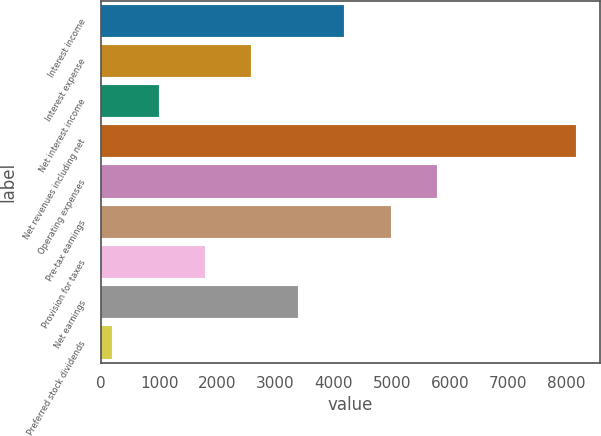Convert chart. <chart><loc_0><loc_0><loc_500><loc_500><bar_chart><fcel>Interest income<fcel>Interest expense<fcel>Net interest income<fcel>Net revenues including net<fcel>Operating expenses<fcel>Pre-tax earnings<fcel>Provision for taxes<fcel>Net earnings<fcel>Preferred stock dividends<nl><fcel>4182<fcel>2586.8<fcel>991.6<fcel>8170<fcel>5777.2<fcel>4979.6<fcel>1789.2<fcel>3384.4<fcel>194<nl></chart> 